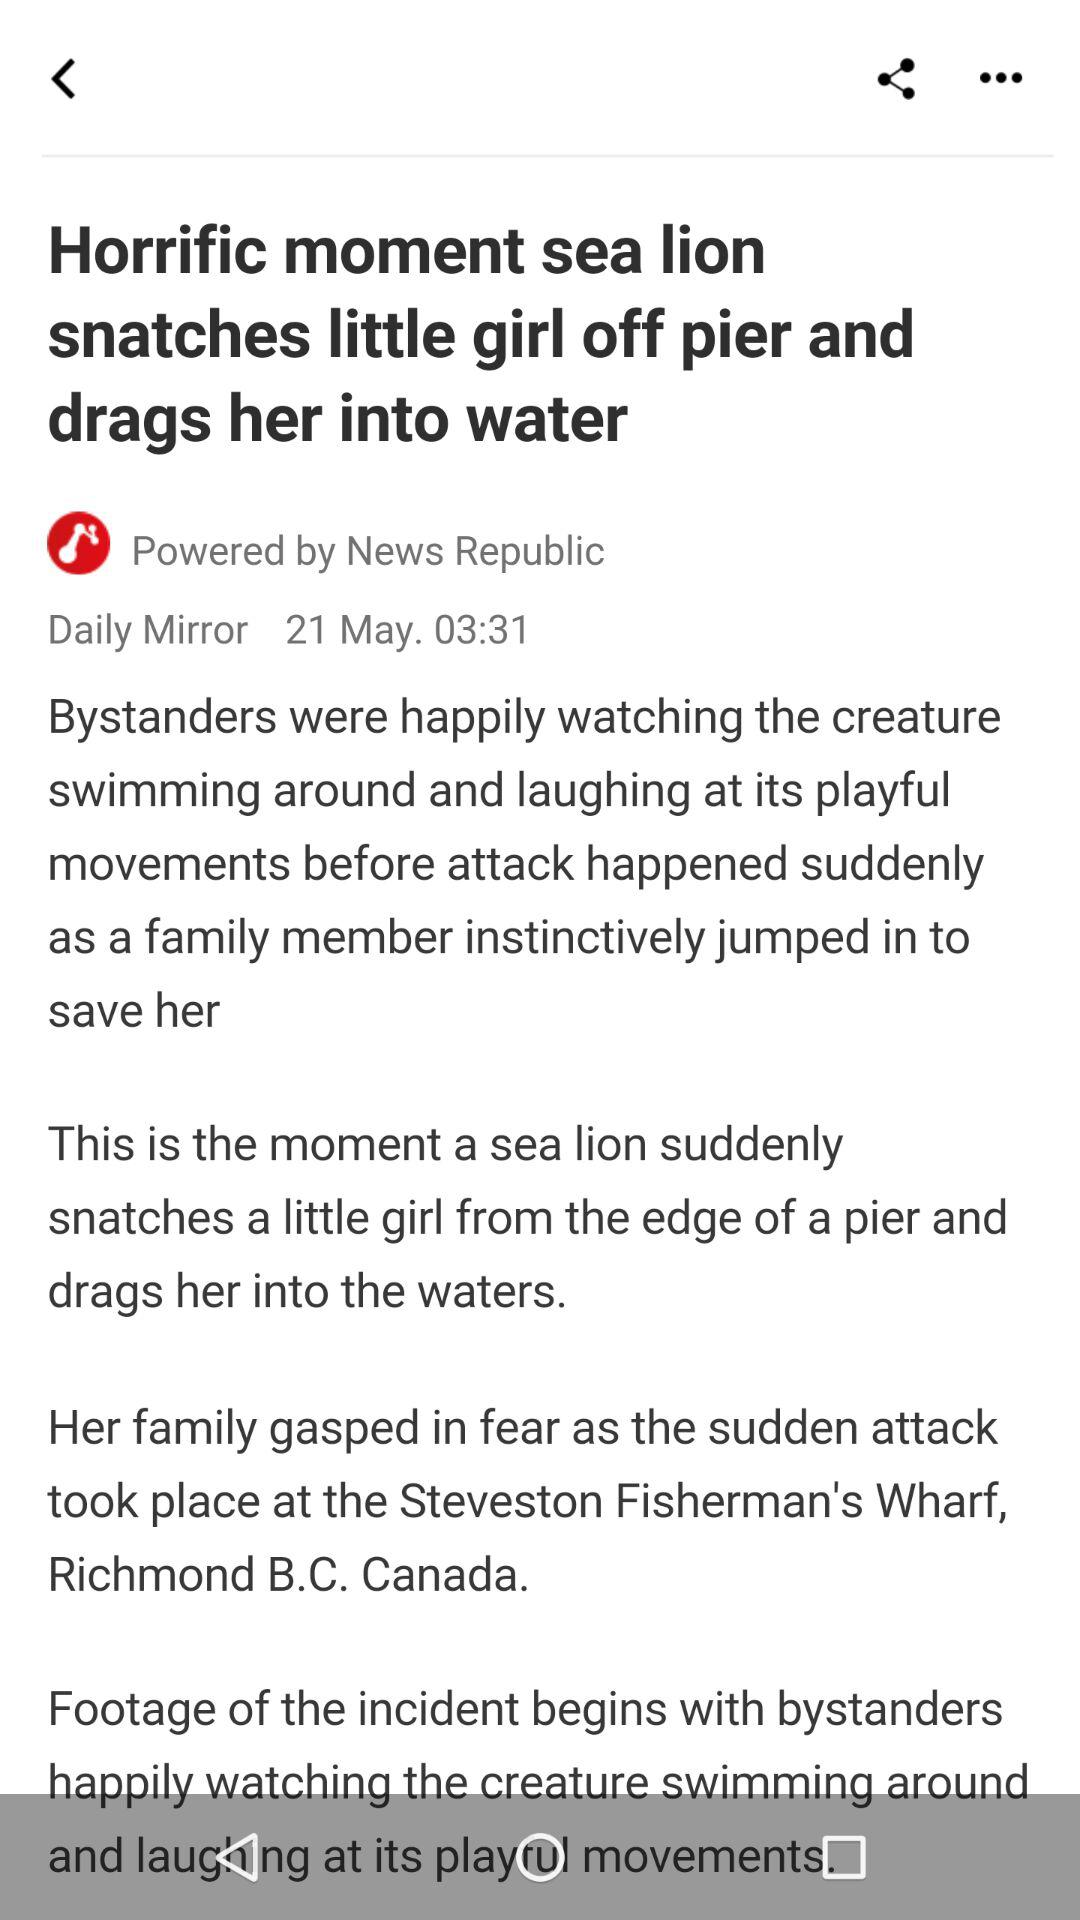Which applications are available for sharing this news story?
When the provided information is insufficient, respond with <no answer>. <no answer> 